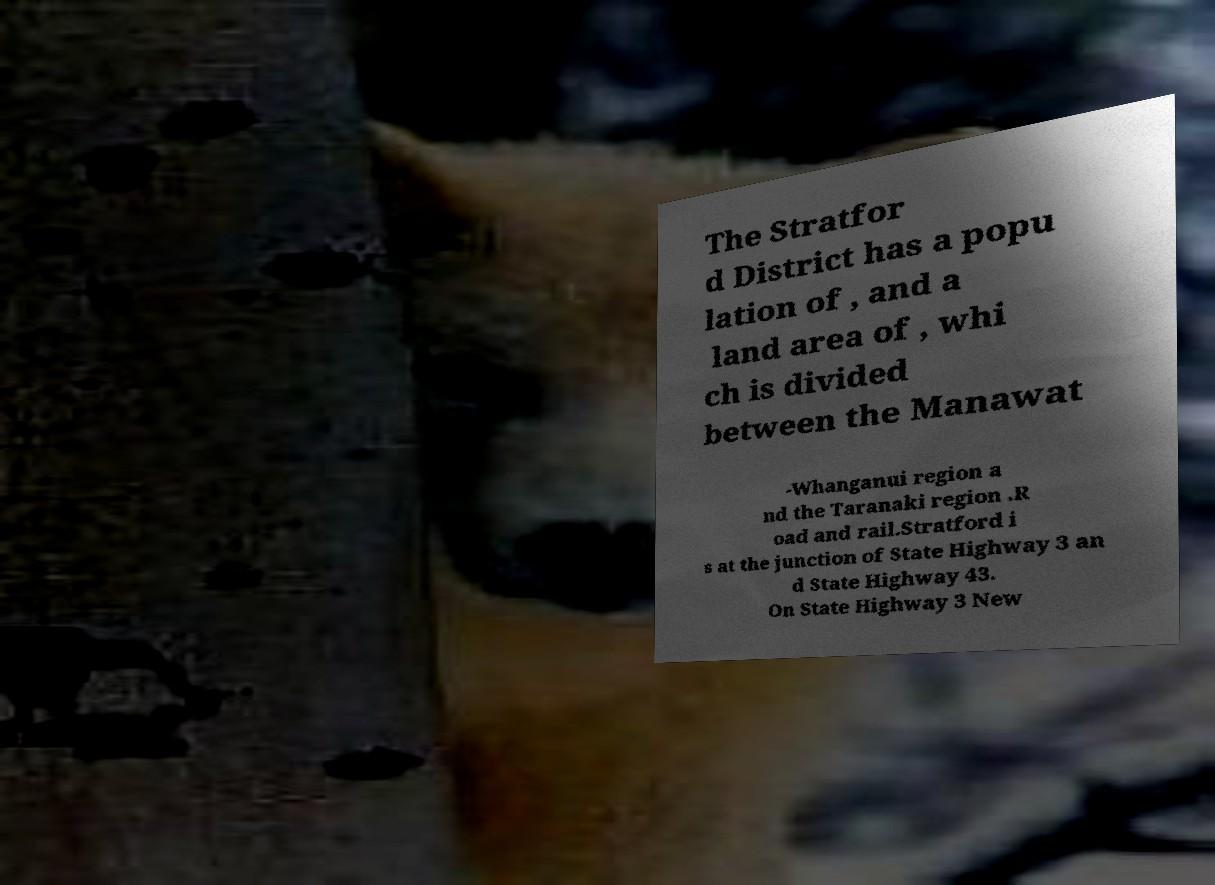There's text embedded in this image that I need extracted. Can you transcribe it verbatim? The Stratfor d District has a popu lation of , and a land area of , whi ch is divided between the Manawat -Whanganui region a nd the Taranaki region .R oad and rail.Stratford i s at the junction of State Highway 3 an d State Highway 43. On State Highway 3 New 